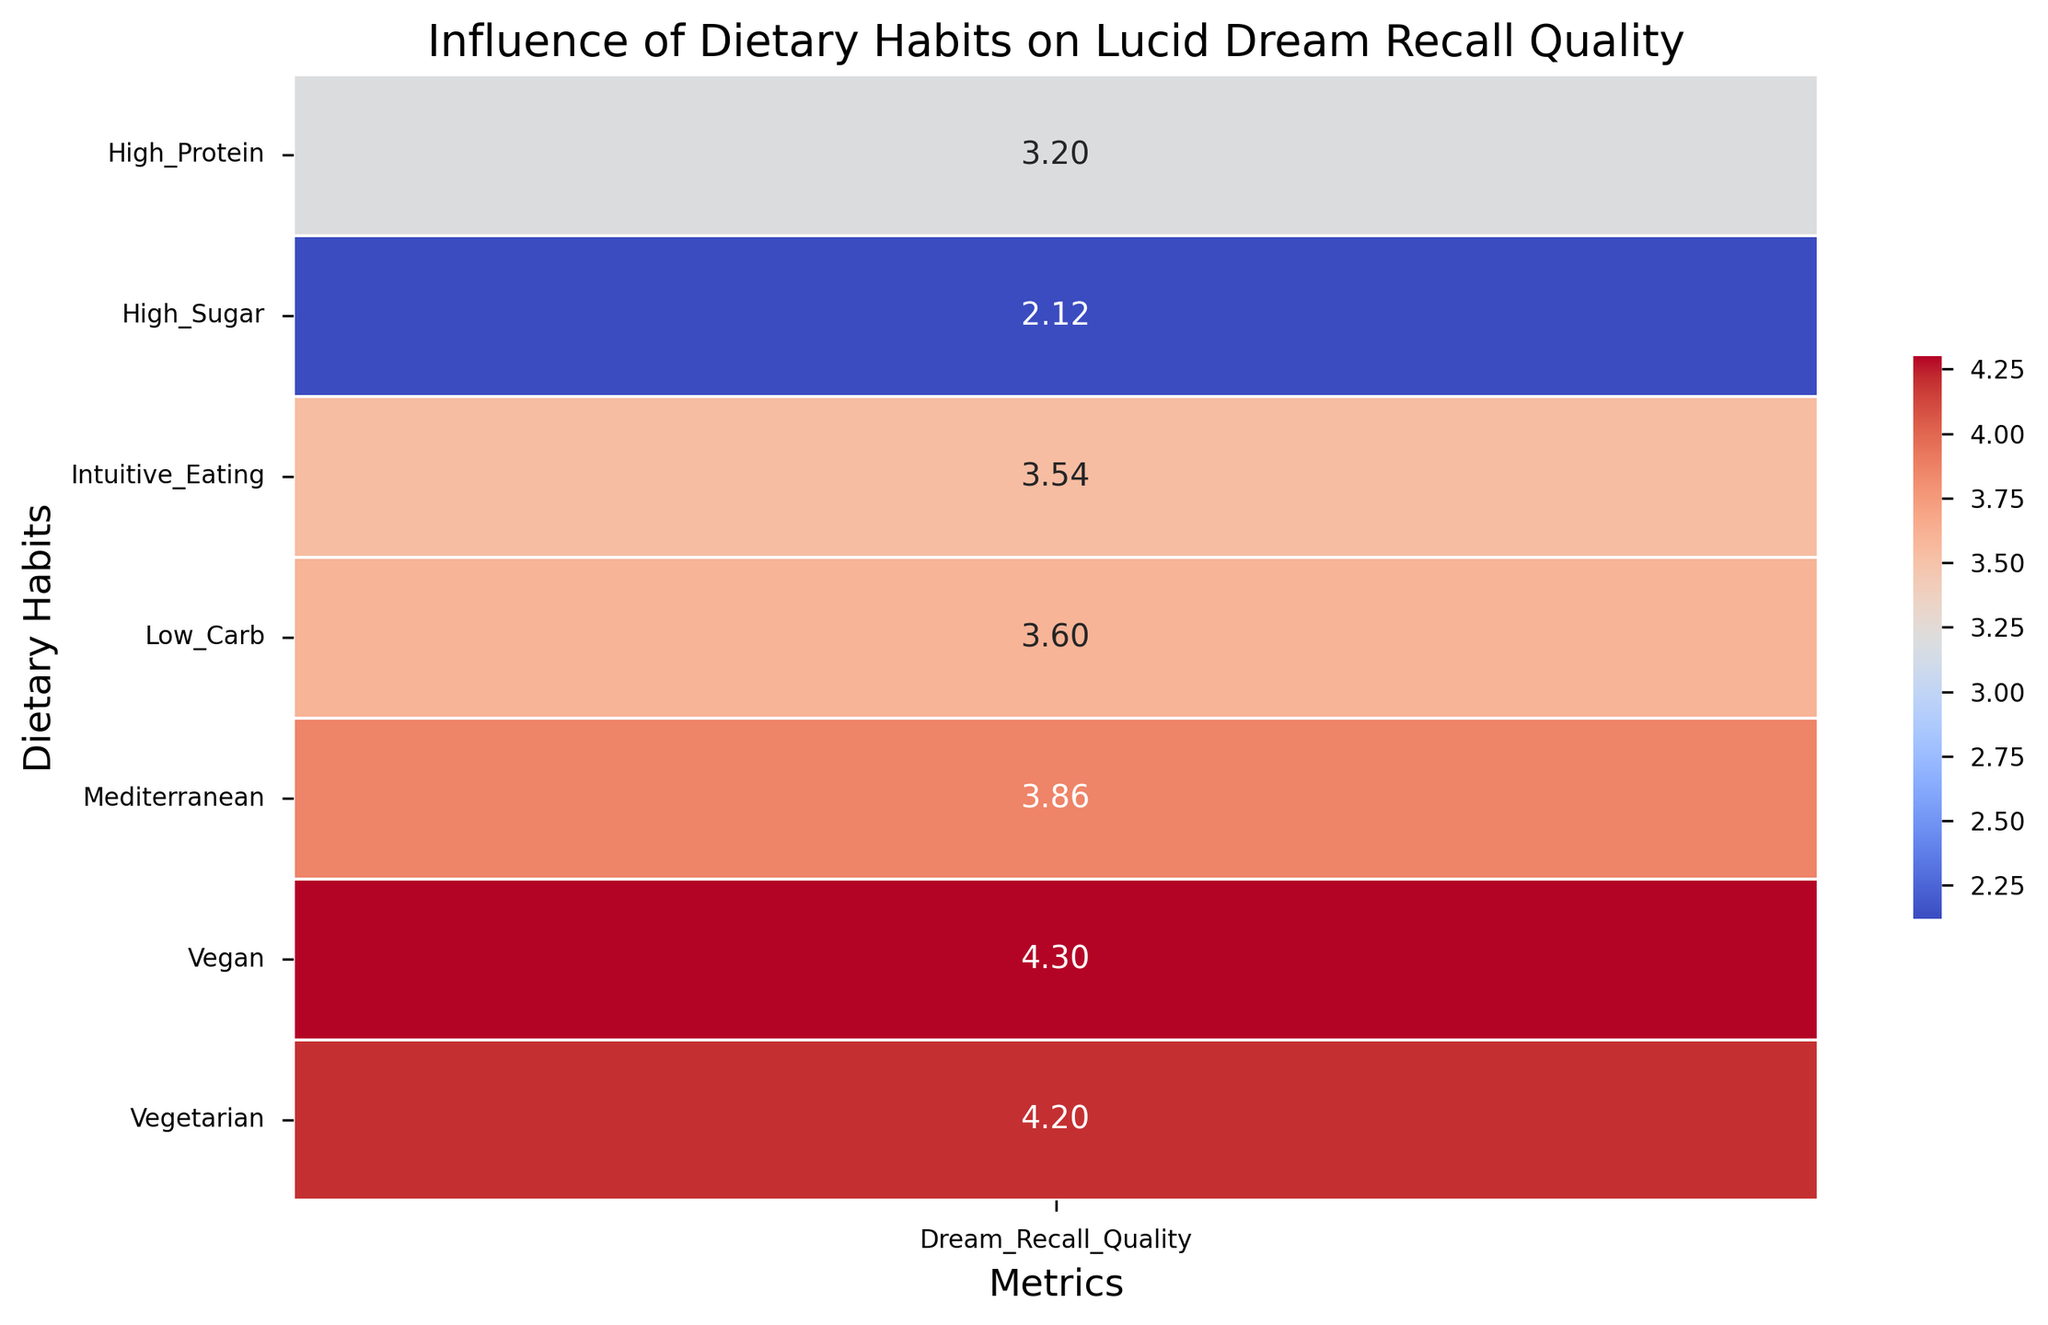What's the average value of Dream Recall Quality for the High Sugar group? There are 5 data points in the High Sugar group: (2.1, 2.5, 1.8, 2.0, 2.2). Sum them up: (2.1 + 2.5 + 1.8 + 2.0 + 2.2) = 10.6, so the average is 10.6/5 = 2.12
Answer: 2.12 Which dietary habit corresponds to the highest Dream Recall Quality? The heatmap displays color intensity where darker shades of red suggest higher values. The Vegetarian group has the highest reported Dream Recall Quality average of 4.2
Answer: Vegetarian Which group has a higher Dream Recall Quality, High Protein or Mediterranean? Compare the average values directly from the heatmap. The High Protein group has an average of 3.2 while the Mediterranean group has an average of 3.86
Answer: Mediterranean How does the Dream Recall Quality of the Vegan group compare to the Low Carb group? Look at the colored intensity of the Vegan (4.3) vs. the Low Carb (3.6) groups. The Vegan group consistently falls in a darker red shade compared to Low Carb
Answer: Vegan has higher quality What's the difference in Dream Recall Quality between the Intuitive Eating and High Protein groups? Check the average values: Intuitive Eating (3.54) and High Protein (3.2). The difference is 3.54 - 3.2 = 0.34
Answer: 0.34 What's the range of Dream Recall Quality values for all dietary habits? Identify the minimum and maximum values from the heatmap. The minimum value is in the High Sugar group (2.12), and the maximum value is in the Vegetarian group (4.2). So, the range is 4.2 - 2.12
Answer: 2.08 Which dietary habit has the most similar Dream Recall Quality to the Vegan group? Comparing all values, the Mediterranean group with a 3.86 is closest to the Vegan group with a 4.3
Answer: Mediterranean Is the Dream Recall Quality of the Low Carb diet higher than the average of all groups combined? Calculate the overall average: (2.12+3.6+3.2+4.2+4.3+3.86+3.54)/7. Sum = 24.82, average = 24.82/7 = 3.55. Compare it to Low Carb’s average (3.6)
Answer: Yes 